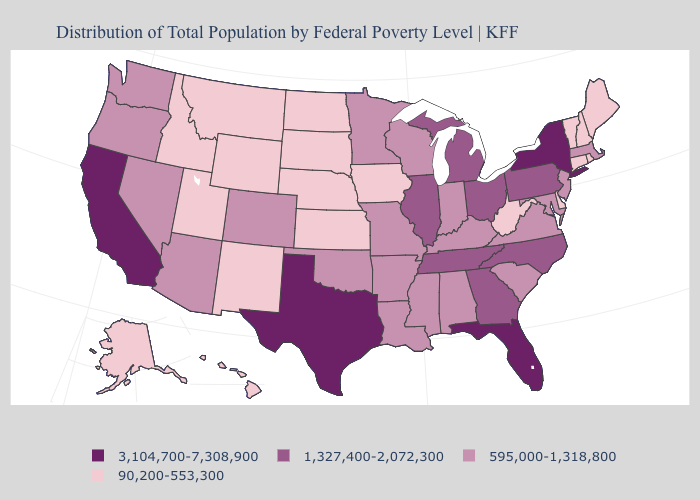Which states hav the highest value in the West?
Short answer required. California. What is the highest value in the West ?
Concise answer only. 3,104,700-7,308,900. Which states hav the highest value in the Northeast?
Answer briefly. New York. What is the value of Montana?
Answer briefly. 90,200-553,300. Name the states that have a value in the range 90,200-553,300?
Be succinct. Alaska, Connecticut, Delaware, Hawaii, Idaho, Iowa, Kansas, Maine, Montana, Nebraska, New Hampshire, New Mexico, North Dakota, Rhode Island, South Dakota, Utah, Vermont, West Virginia, Wyoming. Does Texas have the highest value in the South?
Answer briefly. Yes. Does the map have missing data?
Be succinct. No. Name the states that have a value in the range 3,104,700-7,308,900?
Give a very brief answer. California, Florida, New York, Texas. What is the lowest value in states that border Oklahoma?
Concise answer only. 90,200-553,300. What is the lowest value in states that border Kentucky?
Quick response, please. 90,200-553,300. What is the lowest value in the MidWest?
Give a very brief answer. 90,200-553,300. What is the highest value in the South ?
Short answer required. 3,104,700-7,308,900. Among the states that border Alabama , does Mississippi have the lowest value?
Answer briefly. Yes. What is the highest value in the USA?
Short answer required. 3,104,700-7,308,900. Which states have the lowest value in the South?
Give a very brief answer. Delaware, West Virginia. 